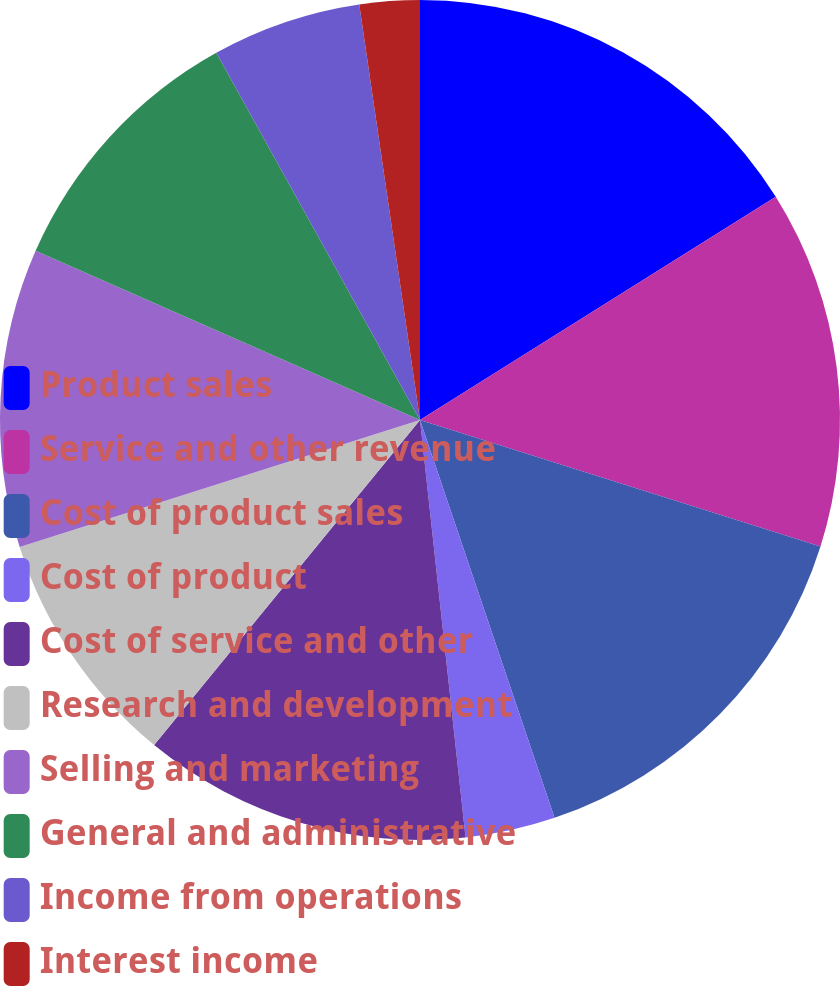Convert chart to OTSL. <chart><loc_0><loc_0><loc_500><loc_500><pie_chart><fcel>Product sales<fcel>Service and other revenue<fcel>Cost of product sales<fcel>Cost of product<fcel>Cost of service and other<fcel>Research and development<fcel>Selling and marketing<fcel>General and administrative<fcel>Income from operations<fcel>Interest income<nl><fcel>16.08%<fcel>13.79%<fcel>14.94%<fcel>3.46%<fcel>12.64%<fcel>9.2%<fcel>11.49%<fcel>10.34%<fcel>5.75%<fcel>2.31%<nl></chart> 